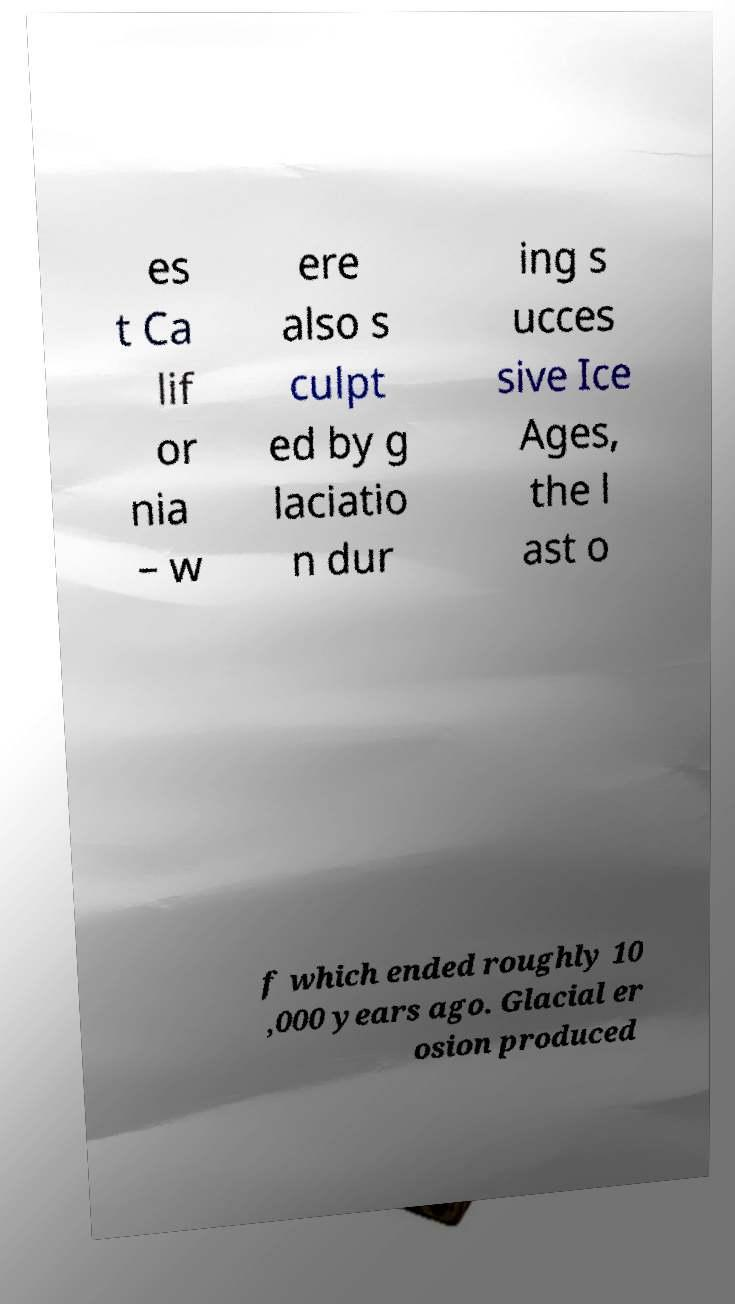I need the written content from this picture converted into text. Can you do that? es t Ca lif or nia – w ere also s culpt ed by g laciatio n dur ing s ucces sive Ice Ages, the l ast o f which ended roughly 10 ,000 years ago. Glacial er osion produced 